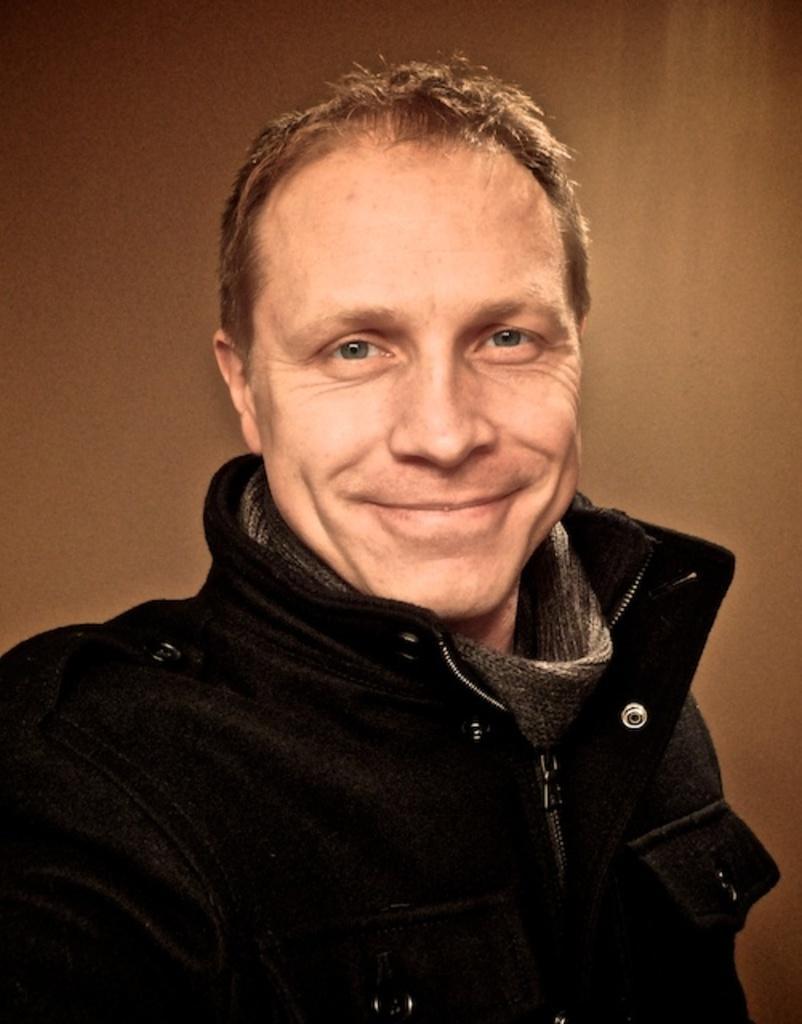Describe this image in one or two sentences. In the center of the image we can see a man smiling. In the background we can see the plain wall. 